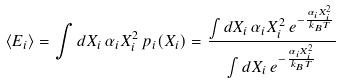Convert formula to latex. <formula><loc_0><loc_0><loc_500><loc_500>\langle E _ { i } \rangle = \int d X _ { i } \, \alpha _ { i } X _ { i } ^ { 2 } \, p _ { i } ( X _ { i } ) = { \frac { \int d X _ { i } \, \alpha _ { i } X _ { i } ^ { 2 } \, e ^ { - { \frac { \alpha _ { i } X _ { i } ^ { 2 } } { k _ { B } T } } } } { \int d X _ { i } \, e ^ { - { \frac { \alpha _ { i } X _ { i } ^ { 2 } } { k _ { B } T } } } } }</formula> 